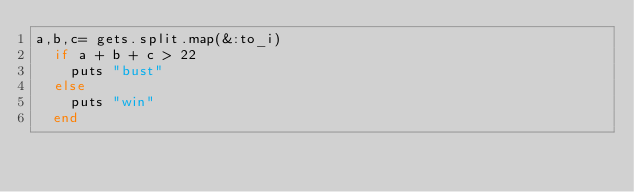<code> <loc_0><loc_0><loc_500><loc_500><_Ruby_>a,b,c= gets.split.map(&:to_i)
  if a + b + c > 22
    puts "bust"
  else
    puts "win"
  end  </code> 